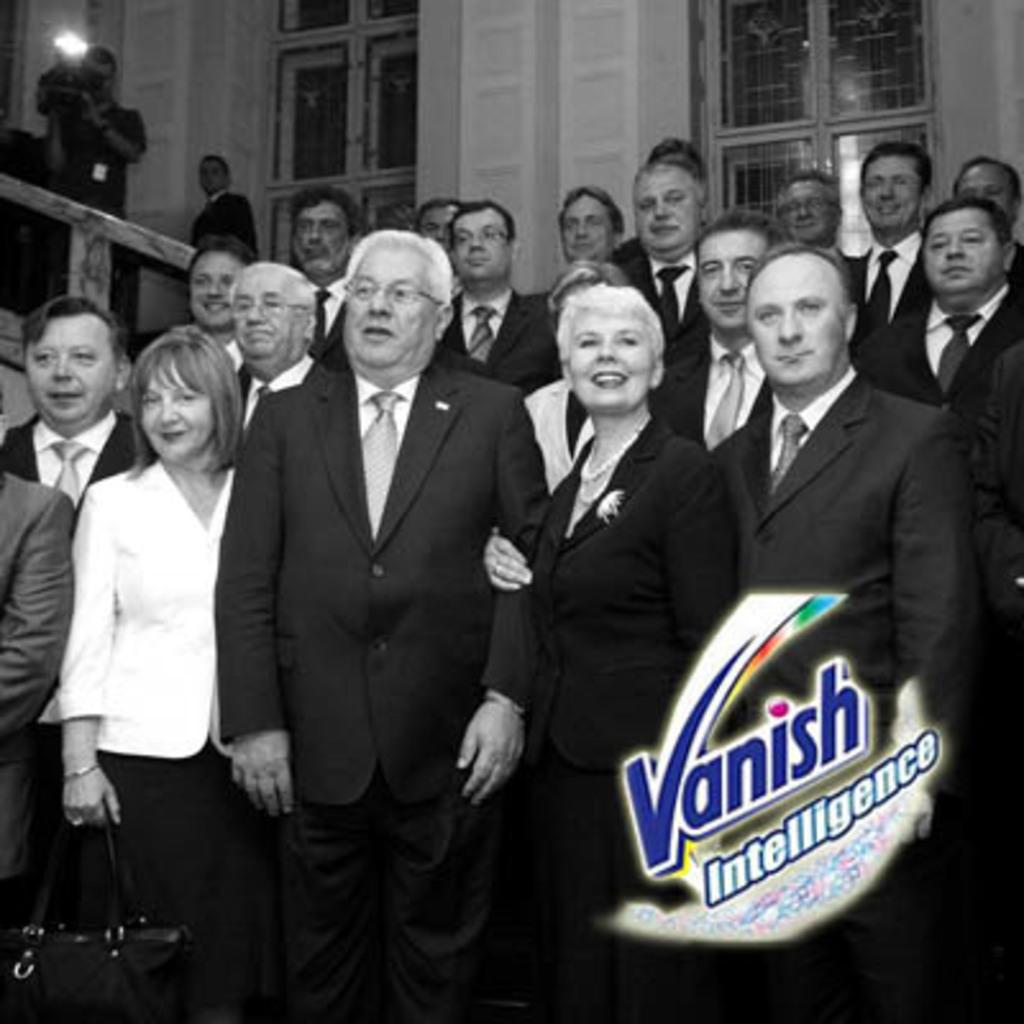What is happening in the image? There are people standing in the image. Can you describe what one of the people is holding? A man is holding a video recorder. What architectural feature can be seen in the image? There are windows in the image. How many boys are playing in the stream in the image? There is no stream or boys present in the image. 